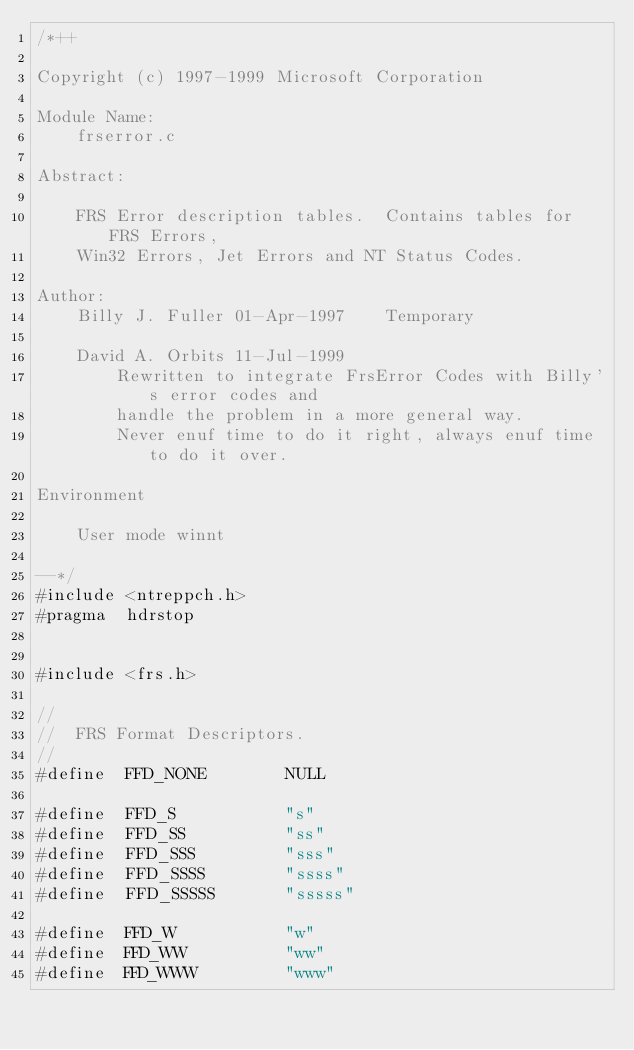Convert code to text. <code><loc_0><loc_0><loc_500><loc_500><_C_>/*++

Copyright (c) 1997-1999 Microsoft Corporation

Module Name:
    frserror.c

Abstract:

    FRS Error description tables.  Contains tables for FRS Errors,
    Win32 Errors, Jet Errors and NT Status Codes.

Author:
    Billy J. Fuller 01-Apr-1997    Temporary

    David A. Orbits 11-Jul-1999
        Rewritten to integrate FrsError Codes with Billy's error codes and
        handle the problem in a more general way.
        Never enuf time to do it right, always enuf time to do it over.

Environment

    User mode winnt

--*/
#include <ntreppch.h>
#pragma  hdrstop


#include <frs.h>

//
//  FRS Format Descriptors.
//
#define  FFD_NONE        NULL

#define  FFD_S           "s"
#define  FFD_SS          "ss"
#define  FFD_SSS         "sss"
#define  FFD_SSSS        "ssss"
#define  FFD_SSSSS       "sssss"

#define  FFD_W           "w"
#define  FFD_WW          "ww"
#define  FFD_WWW         "www"</code> 